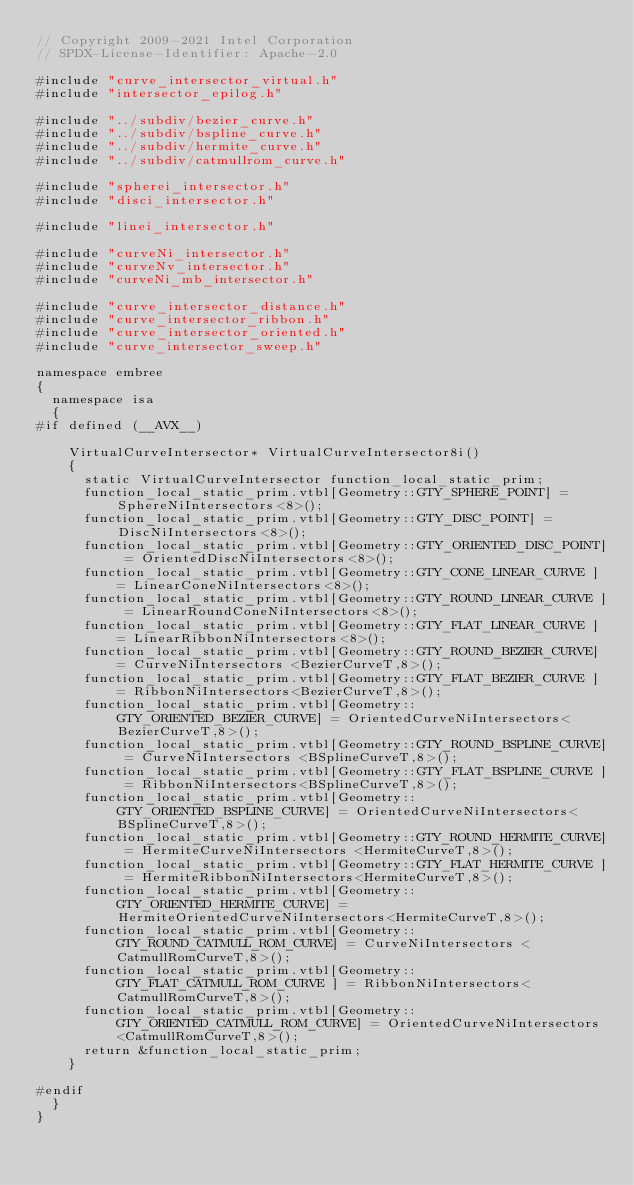<code> <loc_0><loc_0><loc_500><loc_500><_C++_>// Copyright 2009-2021 Intel Corporation
// SPDX-License-Identifier: Apache-2.0
 
#include "curve_intersector_virtual.h"
#include "intersector_epilog.h"

#include "../subdiv/bezier_curve.h"
#include "../subdiv/bspline_curve.h"
#include "../subdiv/hermite_curve.h"
#include "../subdiv/catmullrom_curve.h"

#include "spherei_intersector.h"
#include "disci_intersector.h"

#include "linei_intersector.h"

#include "curveNi_intersector.h"
#include "curveNv_intersector.h"
#include "curveNi_mb_intersector.h"

#include "curve_intersector_distance.h"
#include "curve_intersector_ribbon.h"
#include "curve_intersector_oriented.h"
#include "curve_intersector_sweep.h"

namespace embree
{
  namespace isa
  {
#if defined (__AVX__)
    
    VirtualCurveIntersector* VirtualCurveIntersector8i()
    {
      static VirtualCurveIntersector function_local_static_prim;
      function_local_static_prim.vtbl[Geometry::GTY_SPHERE_POINT] = SphereNiIntersectors<8>();
      function_local_static_prim.vtbl[Geometry::GTY_DISC_POINT] = DiscNiIntersectors<8>();
      function_local_static_prim.vtbl[Geometry::GTY_ORIENTED_DISC_POINT] = OrientedDiscNiIntersectors<8>();
      function_local_static_prim.vtbl[Geometry::GTY_CONE_LINEAR_CURVE ] = LinearConeNiIntersectors<8>();
      function_local_static_prim.vtbl[Geometry::GTY_ROUND_LINEAR_CURVE ] = LinearRoundConeNiIntersectors<8>();
      function_local_static_prim.vtbl[Geometry::GTY_FLAT_LINEAR_CURVE ] = LinearRibbonNiIntersectors<8>();
      function_local_static_prim.vtbl[Geometry::GTY_ROUND_BEZIER_CURVE] = CurveNiIntersectors <BezierCurveT,8>();
      function_local_static_prim.vtbl[Geometry::GTY_FLAT_BEZIER_CURVE ] = RibbonNiIntersectors<BezierCurveT,8>();
      function_local_static_prim.vtbl[Geometry::GTY_ORIENTED_BEZIER_CURVE] = OrientedCurveNiIntersectors<BezierCurveT,8>();
      function_local_static_prim.vtbl[Geometry::GTY_ROUND_BSPLINE_CURVE] = CurveNiIntersectors <BSplineCurveT,8>();
      function_local_static_prim.vtbl[Geometry::GTY_FLAT_BSPLINE_CURVE ] = RibbonNiIntersectors<BSplineCurveT,8>();
      function_local_static_prim.vtbl[Geometry::GTY_ORIENTED_BSPLINE_CURVE] = OrientedCurveNiIntersectors<BSplineCurveT,8>();
      function_local_static_prim.vtbl[Geometry::GTY_ROUND_HERMITE_CURVE] = HermiteCurveNiIntersectors <HermiteCurveT,8>();
      function_local_static_prim.vtbl[Geometry::GTY_FLAT_HERMITE_CURVE ] = HermiteRibbonNiIntersectors<HermiteCurveT,8>();
      function_local_static_prim.vtbl[Geometry::GTY_ORIENTED_HERMITE_CURVE] = HermiteOrientedCurveNiIntersectors<HermiteCurveT,8>();
      function_local_static_prim.vtbl[Geometry::GTY_ROUND_CATMULL_ROM_CURVE] = CurveNiIntersectors <CatmullRomCurveT,8>();
      function_local_static_prim.vtbl[Geometry::GTY_FLAT_CATMULL_ROM_CURVE ] = RibbonNiIntersectors<CatmullRomCurveT,8>();
      function_local_static_prim.vtbl[Geometry::GTY_ORIENTED_CATMULL_ROM_CURVE] = OrientedCurveNiIntersectors<CatmullRomCurveT,8>();
      return &function_local_static_prim;
    }
  
#endif
  }
}
</code> 